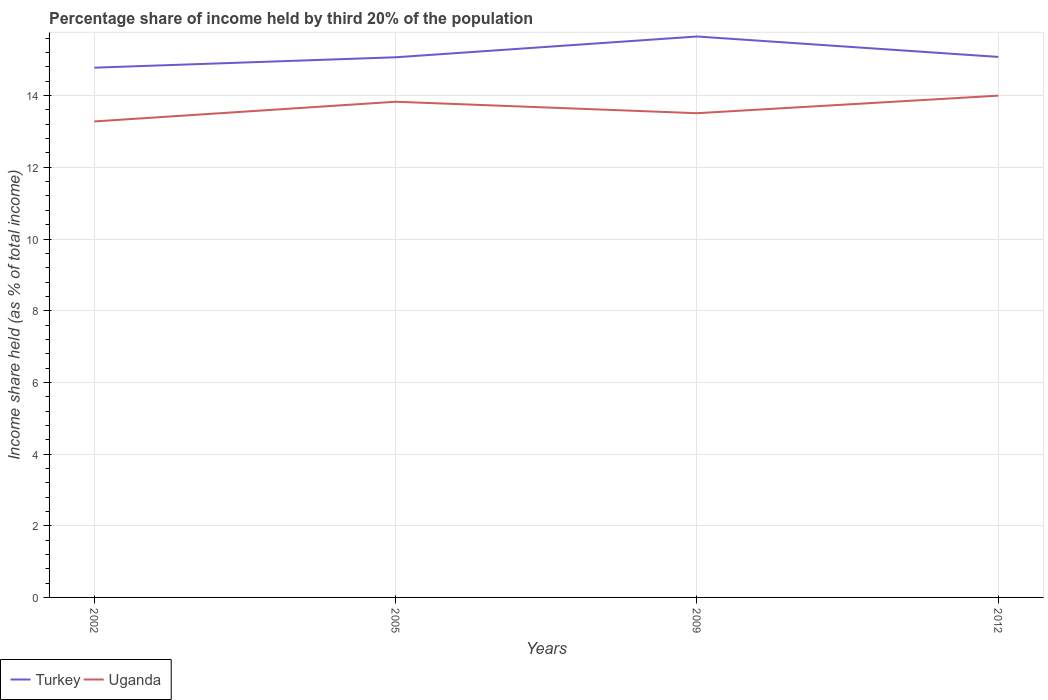How many different coloured lines are there?
Offer a very short reply. 2. Is the number of lines equal to the number of legend labels?
Make the answer very short. Yes. Across all years, what is the maximum share of income held by third 20% of the population in Uganda?
Ensure brevity in your answer.  13.28. In which year was the share of income held by third 20% of the population in Uganda maximum?
Your answer should be very brief. 2002. What is the total share of income held by third 20% of the population in Uganda in the graph?
Your response must be concise. -0.55. What is the difference between the highest and the second highest share of income held by third 20% of the population in Turkey?
Make the answer very short. 0.87. How many lines are there?
Offer a terse response. 2. How many years are there in the graph?
Your response must be concise. 4. What is the title of the graph?
Your answer should be very brief. Percentage share of income held by third 20% of the population. Does "Tanzania" appear as one of the legend labels in the graph?
Provide a succinct answer. No. What is the label or title of the X-axis?
Your answer should be compact. Years. What is the label or title of the Y-axis?
Make the answer very short. Income share held (as % of total income). What is the Income share held (as % of total income) of Turkey in 2002?
Make the answer very short. 14.78. What is the Income share held (as % of total income) in Uganda in 2002?
Your response must be concise. 13.28. What is the Income share held (as % of total income) of Turkey in 2005?
Ensure brevity in your answer.  15.07. What is the Income share held (as % of total income) of Uganda in 2005?
Give a very brief answer. 13.83. What is the Income share held (as % of total income) in Turkey in 2009?
Your response must be concise. 15.65. What is the Income share held (as % of total income) in Uganda in 2009?
Provide a short and direct response. 13.51. What is the Income share held (as % of total income) of Turkey in 2012?
Offer a very short reply. 15.08. What is the Income share held (as % of total income) in Uganda in 2012?
Give a very brief answer. 14. Across all years, what is the maximum Income share held (as % of total income) of Turkey?
Keep it short and to the point. 15.65. Across all years, what is the maximum Income share held (as % of total income) of Uganda?
Offer a terse response. 14. Across all years, what is the minimum Income share held (as % of total income) in Turkey?
Your response must be concise. 14.78. Across all years, what is the minimum Income share held (as % of total income) of Uganda?
Your answer should be very brief. 13.28. What is the total Income share held (as % of total income) in Turkey in the graph?
Offer a terse response. 60.58. What is the total Income share held (as % of total income) of Uganda in the graph?
Provide a succinct answer. 54.62. What is the difference between the Income share held (as % of total income) of Turkey in 2002 and that in 2005?
Provide a succinct answer. -0.29. What is the difference between the Income share held (as % of total income) of Uganda in 2002 and that in 2005?
Your answer should be very brief. -0.55. What is the difference between the Income share held (as % of total income) of Turkey in 2002 and that in 2009?
Your answer should be compact. -0.87. What is the difference between the Income share held (as % of total income) in Uganda in 2002 and that in 2009?
Make the answer very short. -0.23. What is the difference between the Income share held (as % of total income) in Turkey in 2002 and that in 2012?
Offer a very short reply. -0.3. What is the difference between the Income share held (as % of total income) of Uganda in 2002 and that in 2012?
Keep it short and to the point. -0.72. What is the difference between the Income share held (as % of total income) of Turkey in 2005 and that in 2009?
Offer a terse response. -0.58. What is the difference between the Income share held (as % of total income) in Uganda in 2005 and that in 2009?
Offer a very short reply. 0.32. What is the difference between the Income share held (as % of total income) of Turkey in 2005 and that in 2012?
Ensure brevity in your answer.  -0.01. What is the difference between the Income share held (as % of total income) in Uganda in 2005 and that in 2012?
Your response must be concise. -0.17. What is the difference between the Income share held (as % of total income) of Turkey in 2009 and that in 2012?
Provide a short and direct response. 0.57. What is the difference between the Income share held (as % of total income) in Uganda in 2009 and that in 2012?
Provide a short and direct response. -0.49. What is the difference between the Income share held (as % of total income) of Turkey in 2002 and the Income share held (as % of total income) of Uganda in 2005?
Give a very brief answer. 0.95. What is the difference between the Income share held (as % of total income) in Turkey in 2002 and the Income share held (as % of total income) in Uganda in 2009?
Keep it short and to the point. 1.27. What is the difference between the Income share held (as % of total income) in Turkey in 2002 and the Income share held (as % of total income) in Uganda in 2012?
Provide a short and direct response. 0.78. What is the difference between the Income share held (as % of total income) of Turkey in 2005 and the Income share held (as % of total income) of Uganda in 2009?
Your response must be concise. 1.56. What is the difference between the Income share held (as % of total income) in Turkey in 2005 and the Income share held (as % of total income) in Uganda in 2012?
Provide a succinct answer. 1.07. What is the difference between the Income share held (as % of total income) of Turkey in 2009 and the Income share held (as % of total income) of Uganda in 2012?
Your answer should be very brief. 1.65. What is the average Income share held (as % of total income) of Turkey per year?
Your answer should be very brief. 15.14. What is the average Income share held (as % of total income) in Uganda per year?
Your answer should be compact. 13.65. In the year 2002, what is the difference between the Income share held (as % of total income) of Turkey and Income share held (as % of total income) of Uganda?
Offer a very short reply. 1.5. In the year 2005, what is the difference between the Income share held (as % of total income) in Turkey and Income share held (as % of total income) in Uganda?
Ensure brevity in your answer.  1.24. In the year 2009, what is the difference between the Income share held (as % of total income) of Turkey and Income share held (as % of total income) of Uganda?
Provide a short and direct response. 2.14. What is the ratio of the Income share held (as % of total income) in Turkey in 2002 to that in 2005?
Give a very brief answer. 0.98. What is the ratio of the Income share held (as % of total income) in Uganda in 2002 to that in 2005?
Keep it short and to the point. 0.96. What is the ratio of the Income share held (as % of total income) in Uganda in 2002 to that in 2009?
Your answer should be very brief. 0.98. What is the ratio of the Income share held (as % of total income) of Turkey in 2002 to that in 2012?
Give a very brief answer. 0.98. What is the ratio of the Income share held (as % of total income) in Uganda in 2002 to that in 2012?
Give a very brief answer. 0.95. What is the ratio of the Income share held (as % of total income) of Turkey in 2005 to that in 2009?
Give a very brief answer. 0.96. What is the ratio of the Income share held (as % of total income) of Uganda in 2005 to that in 2009?
Give a very brief answer. 1.02. What is the ratio of the Income share held (as % of total income) of Uganda in 2005 to that in 2012?
Make the answer very short. 0.99. What is the ratio of the Income share held (as % of total income) of Turkey in 2009 to that in 2012?
Keep it short and to the point. 1.04. What is the ratio of the Income share held (as % of total income) of Uganda in 2009 to that in 2012?
Provide a succinct answer. 0.96. What is the difference between the highest and the second highest Income share held (as % of total income) of Turkey?
Ensure brevity in your answer.  0.57. What is the difference between the highest and the second highest Income share held (as % of total income) in Uganda?
Make the answer very short. 0.17. What is the difference between the highest and the lowest Income share held (as % of total income) in Turkey?
Ensure brevity in your answer.  0.87. What is the difference between the highest and the lowest Income share held (as % of total income) of Uganda?
Provide a short and direct response. 0.72. 